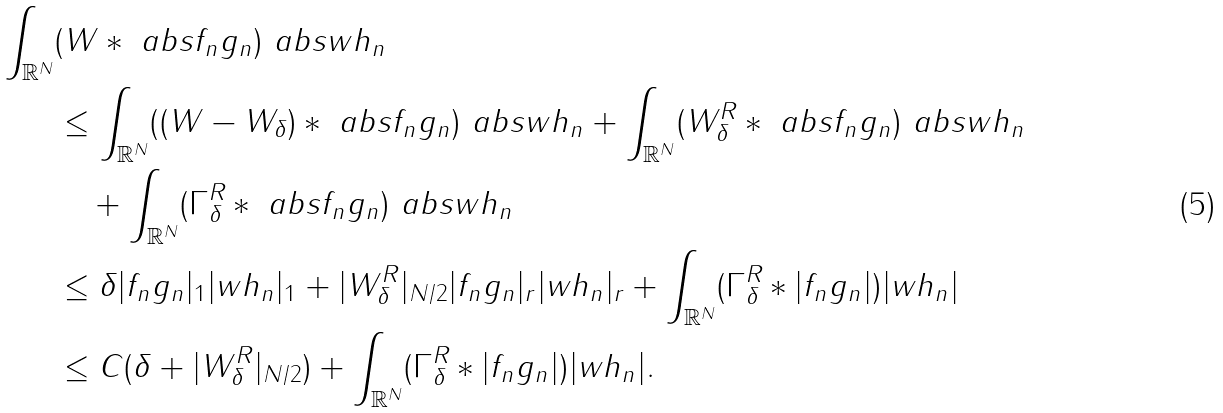<formula> <loc_0><loc_0><loc_500><loc_500>\int _ { \mathbb { R } ^ { N } } & ( W * \ a b s { f _ { n } g _ { n } } ) \ a b s { w h _ { n } } \\ & \leq \int _ { \mathbb { R } ^ { N } } ( ( W - W _ { \delta } ) * \ a b s { f _ { n } g _ { n } } ) \ a b s { w h _ { n } } + \int _ { \mathbb { R } ^ { N } } ( W ^ { R } _ { \delta } * \ a b s { f _ { n } g _ { n } } ) \ a b s { w h _ { n } } \\ & \quad + \int _ { \mathbb { R } ^ { N } } ( \Gamma ^ { R } _ { \delta } * \ a b s { f _ { n } g _ { n } } ) \ a b s { w h _ { n } } \\ & \leq \delta | f _ { n } g _ { n } | _ { 1 } | w h _ { n } | _ { 1 } + | W ^ { R } _ { \delta } | _ { N / 2 } | f _ { n } g _ { n } | _ { r } | w h _ { n } | _ { r } + \int _ { \mathbb { R } ^ { N } } ( \Gamma _ { \delta } ^ { R } * | f _ { n } g _ { n } | ) | w h _ { n } | \\ & \leq C ( \delta + | W ^ { R } _ { \delta } | _ { N / 2 } ) + \int _ { \mathbb { R } ^ { N } } ( \Gamma _ { \delta } ^ { R } * | f _ { n } g _ { n } | ) | w h _ { n } | . \\</formula> 